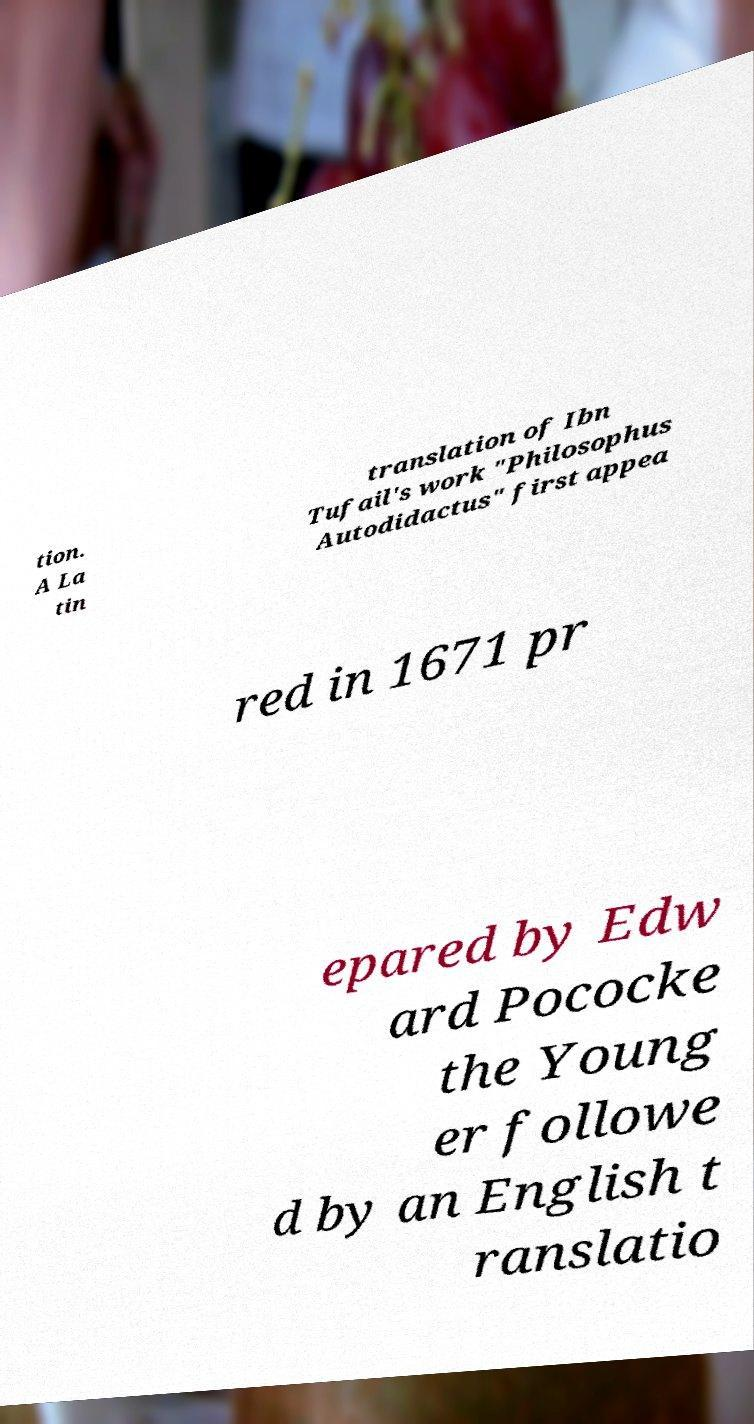What messages or text are displayed in this image? I need them in a readable, typed format. tion. A La tin translation of Ibn Tufail's work "Philosophus Autodidactus" first appea red in 1671 pr epared by Edw ard Pococke the Young er followe d by an English t ranslatio 